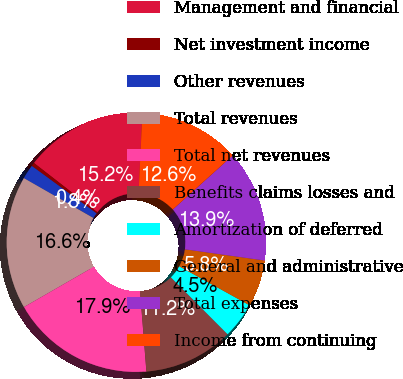<chart> <loc_0><loc_0><loc_500><loc_500><pie_chart><fcel>Management and financial<fcel>Net investment income<fcel>Other revenues<fcel>Total revenues<fcel>Total net revenues<fcel>Benefits claims losses and<fcel>Amortization of deferred<fcel>General and administrative<fcel>Total expenses<fcel>Income from continuing<nl><fcel>15.25%<fcel>0.45%<fcel>1.79%<fcel>16.59%<fcel>17.94%<fcel>11.21%<fcel>4.48%<fcel>5.83%<fcel>13.9%<fcel>12.56%<nl></chart> 